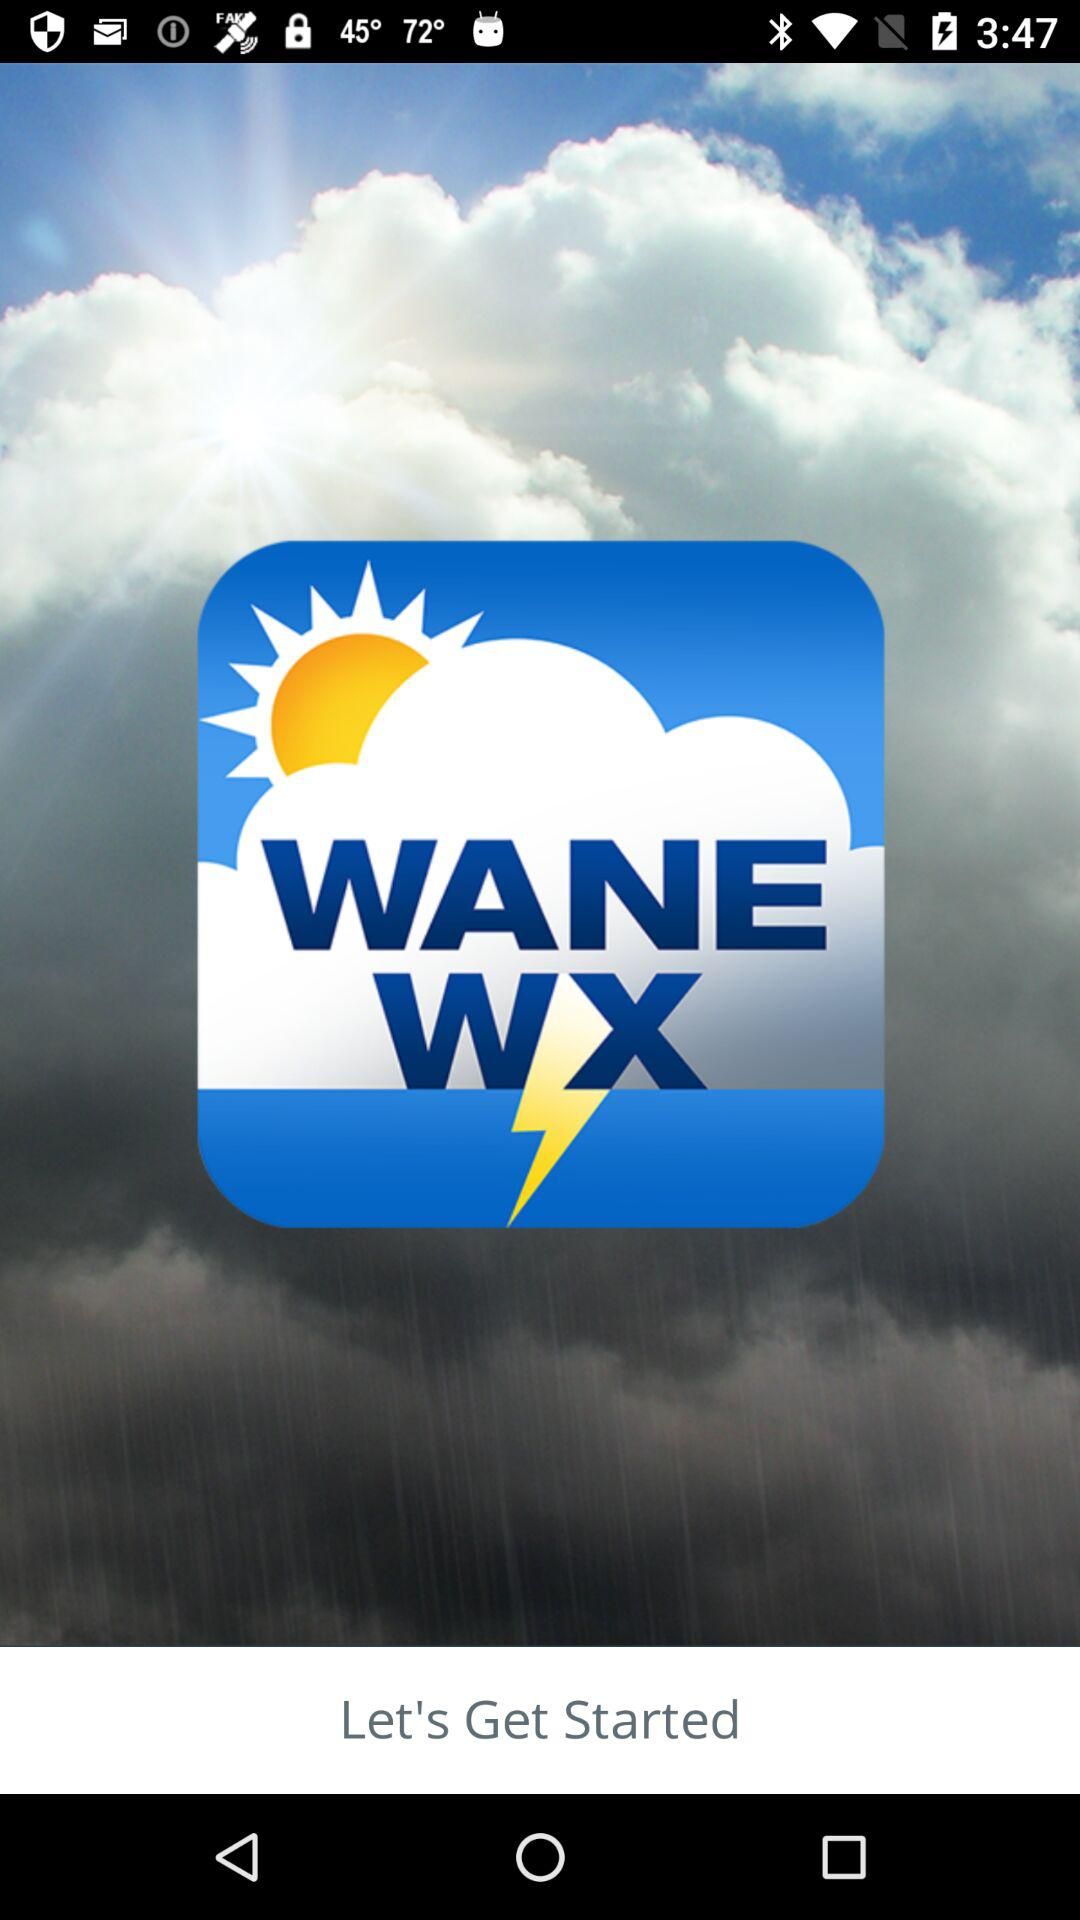When was the last weather update?
When the provided information is insufficient, respond with <no answer>. <no answer> 